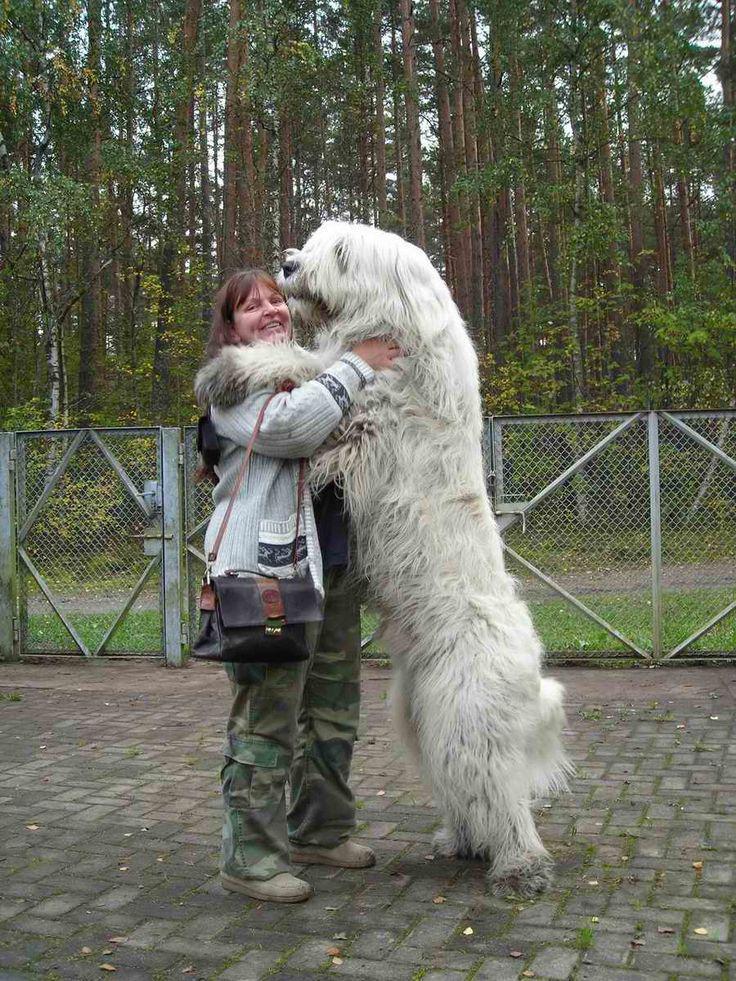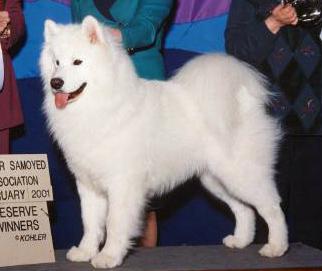The first image is the image on the left, the second image is the image on the right. Assess this claim about the two images: "One of the dogs is lying down on grass.". Correct or not? Answer yes or no. No. 